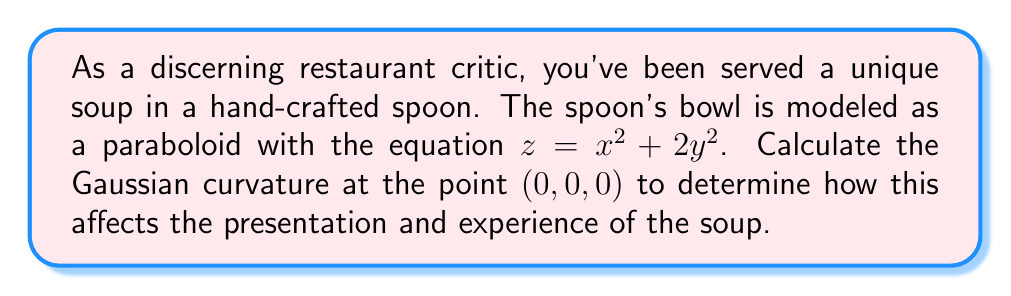Show me your answer to this math problem. To calculate the Gaussian curvature of the spoon's surface at the point (0, 0, 0), we'll follow these steps:

1. The surface is given by $z = f(x,y) = x^2 + 2y^2$

2. Calculate the first and second partial derivatives:
   $f_x = 2x$,  $f_y = 4y$
   $f_{xx} = 2$, $f_{yy} = 4$, $f_{xy} = f_{yx} = 0$

3. At the point (0, 0, 0):
   $f_x = 0$, $f_y = 0$
   $f_{xx} = 2$, $f_{yy} = 4$, $f_{xy} = 0$

4. The first fundamental form coefficients are:
   $E = 1 + f_x^2 = 1$
   $F = f_x f_y = 0$
   $G = 1 + f_y^2 = 1$

5. The second fundamental form coefficients are:
   $L = \frac{f_{xx}}{\sqrt{1 + f_x^2 + f_y^2}} = 2$
   $M = \frac{f_{xy}}{\sqrt{1 + f_x^2 + f_y^2}} = 0$
   $N = \frac{f_{yy}}{\sqrt{1 + f_x^2 + f_y^2}} = 4$

6. The Gaussian curvature is given by:
   $$K = \frac{LN - M^2}{EG - F^2}$$

7. Substituting the values:
   $$K = \frac{(2)(4) - 0^2}{(1)(1) - 0^2} = \frac{8}{1} = 8$$

Therefore, the Gaussian curvature at the point (0, 0, 0) is 8.
Answer: $K = 8$ 